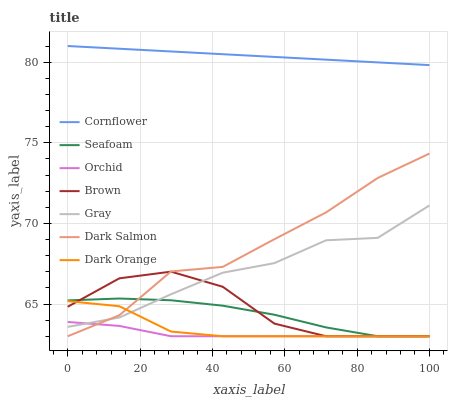Does Orchid have the minimum area under the curve?
Answer yes or no. Yes. Does Cornflower have the maximum area under the curve?
Answer yes or no. Yes. Does Brown have the minimum area under the curve?
Answer yes or no. No. Does Brown have the maximum area under the curve?
Answer yes or no. No. Is Cornflower the smoothest?
Answer yes or no. Yes. Is Dark Salmon the roughest?
Answer yes or no. Yes. Is Brown the smoothest?
Answer yes or no. No. Is Brown the roughest?
Answer yes or no. No. Does Brown have the lowest value?
Answer yes or no. Yes. Does Gray have the lowest value?
Answer yes or no. No. Does Cornflower have the highest value?
Answer yes or no. Yes. Does Brown have the highest value?
Answer yes or no. No. Is Dark Orange less than Cornflower?
Answer yes or no. Yes. Is Cornflower greater than Orchid?
Answer yes or no. Yes. Does Gray intersect Dark Salmon?
Answer yes or no. Yes. Is Gray less than Dark Salmon?
Answer yes or no. No. Is Gray greater than Dark Salmon?
Answer yes or no. No. Does Dark Orange intersect Cornflower?
Answer yes or no. No. 